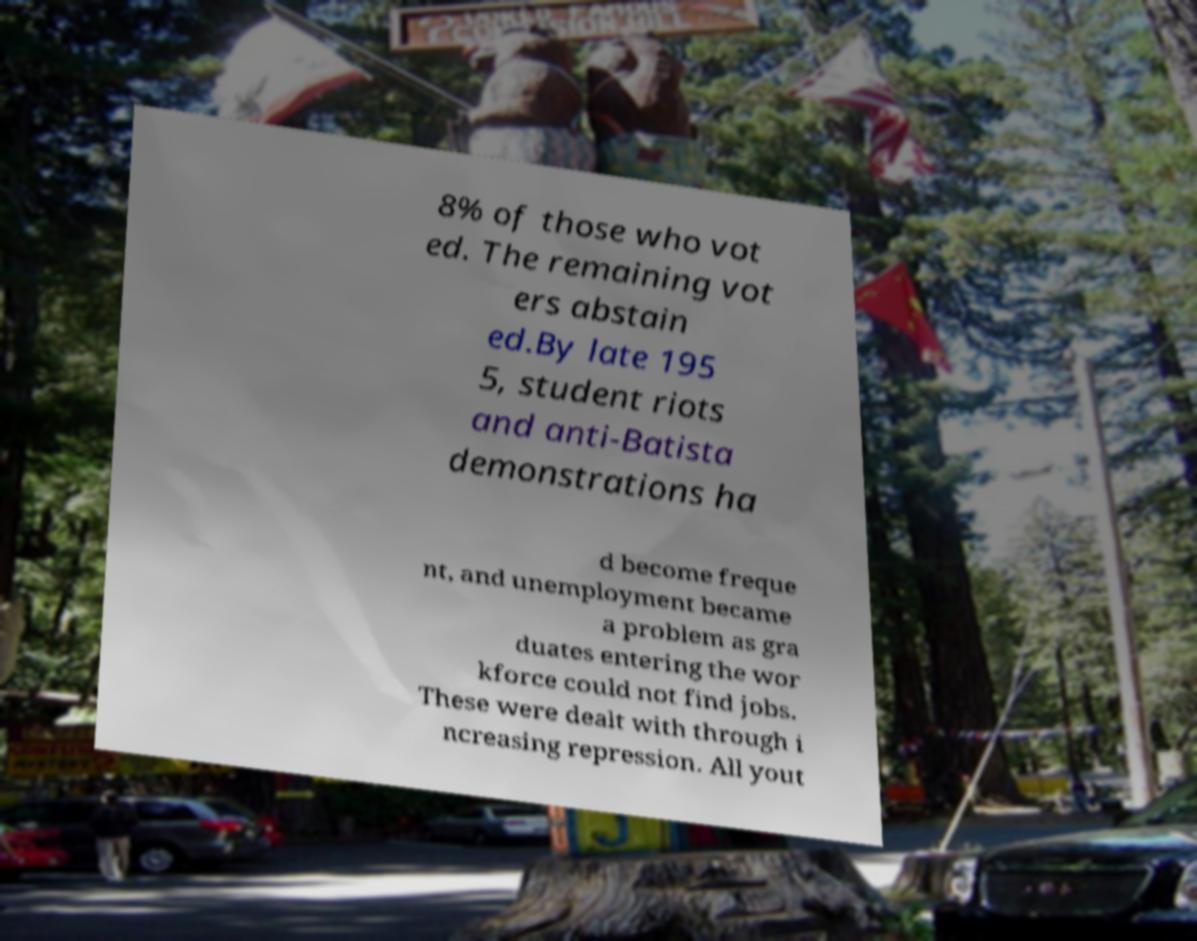Please read and relay the text visible in this image. What does it say? 8% of those who vot ed. The remaining vot ers abstain ed.By late 195 5, student riots and anti-Batista demonstrations ha d become freque nt, and unemployment became a problem as gra duates entering the wor kforce could not find jobs. These were dealt with through i ncreasing repression. All yout 